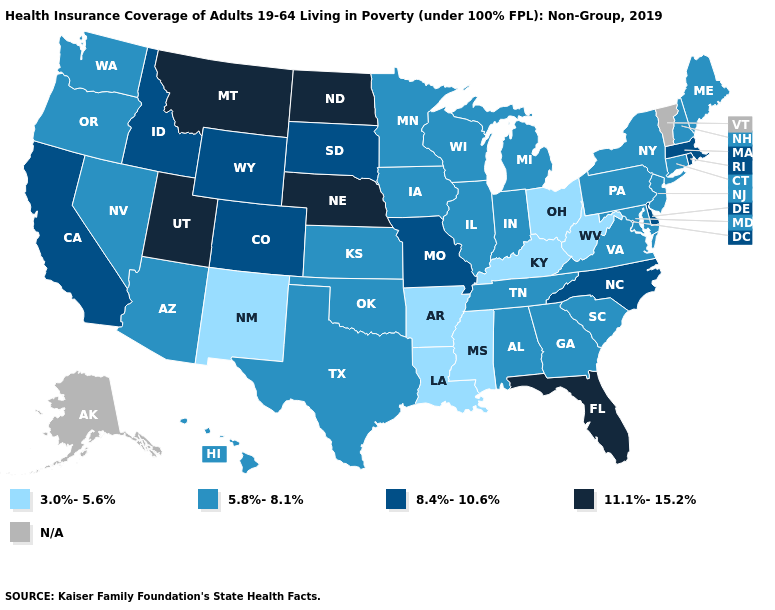What is the lowest value in states that border Montana?
Concise answer only. 8.4%-10.6%. Among the states that border Oregon , does California have the highest value?
Keep it brief. Yes. Name the states that have a value in the range 11.1%-15.2%?
Give a very brief answer. Florida, Montana, Nebraska, North Dakota, Utah. Does Mississippi have the lowest value in the USA?
Quick response, please. Yes. Name the states that have a value in the range N/A?
Answer briefly. Alaska, Vermont. Name the states that have a value in the range 8.4%-10.6%?
Short answer required. California, Colorado, Delaware, Idaho, Massachusetts, Missouri, North Carolina, Rhode Island, South Dakota, Wyoming. Name the states that have a value in the range N/A?
Keep it brief. Alaska, Vermont. Which states have the lowest value in the USA?
Be succinct. Arkansas, Kentucky, Louisiana, Mississippi, New Mexico, Ohio, West Virginia. Among the states that border Georgia , which have the highest value?
Write a very short answer. Florida. What is the value of Maine?
Give a very brief answer. 5.8%-8.1%. Which states have the lowest value in the Northeast?
Keep it brief. Connecticut, Maine, New Hampshire, New Jersey, New York, Pennsylvania. Does Hawaii have the highest value in the West?
Give a very brief answer. No. Which states have the lowest value in the Northeast?
Concise answer only. Connecticut, Maine, New Hampshire, New Jersey, New York, Pennsylvania. What is the highest value in states that border New York?
Keep it brief. 8.4%-10.6%. What is the highest value in the MidWest ?
Write a very short answer. 11.1%-15.2%. 